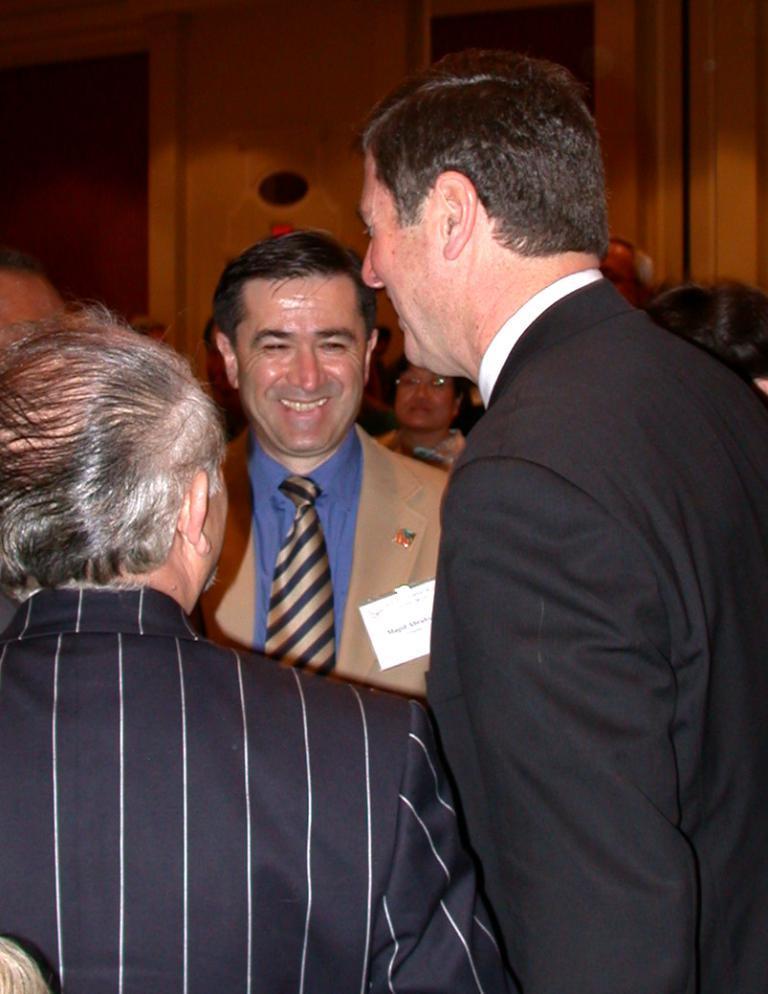Can you describe this image briefly? There are many people. One person is wearing a badge. In the back there is a wooden wall. 